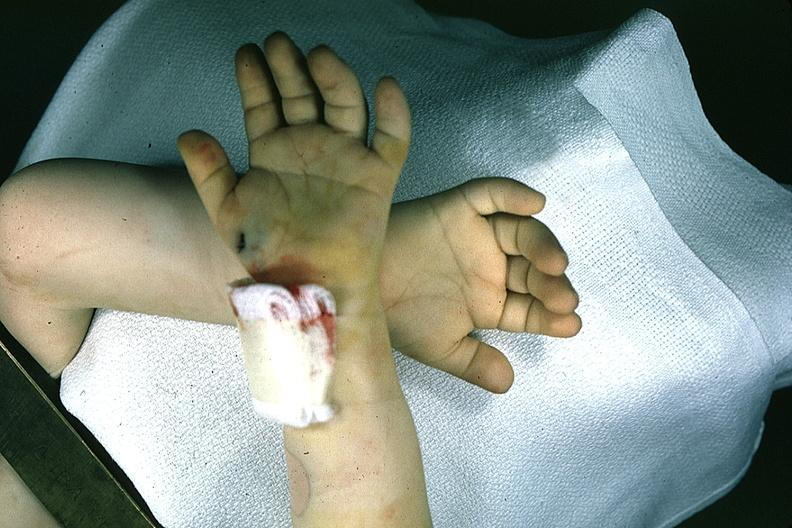does this image show hands one with simian crease?
Answer the question using a single word or phrase. Yes 